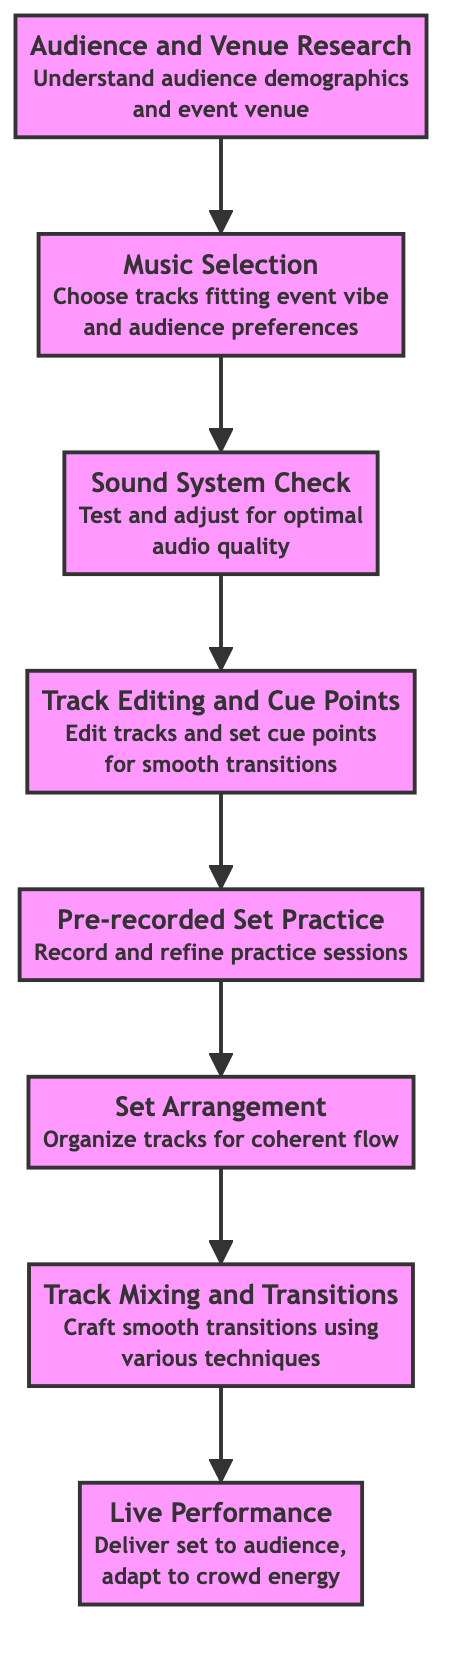What is the first step in planning a DJ set? The diagram indicates that the first step is "Audience and Venue Research," which is at the bottom and leads to music selection.
Answer: Audience and Venue Research How many nodes are in the flowchart? Counting all the elements listed in the diagram, there are eight distinct nodes representing different steps in planning a DJ set.
Answer: Eight Which step directly follows "Music Selection"? According to the diagram, the step that follows "Music Selection" is "Sound System Check." This is determined by the upward flow from node 07 to node 06.
Answer: Sound System Check What is the last step before the live performance? The diagram shows that the step prior to "Live Performance" is "Track Mixing and Transitions," which indicates that the transitions should be polished just before performing live.
Answer: Track Mixing and Transitions Why is "Pre-recorded Set Practice" important? The diagram implies the importance of "Pre-recorded Set Practice" as it allows the DJ to refine transitions and overall set flow, indicating it serves as a critical revision step before the live performance.
Answer: Refine transitions How does "Set Arrangement" relate to "Music Selection"? "Set Arrangement" follows "Music Selection" in the flowchart, indicating that after selecting music, the next logical step is to organize it into a coherent set, showcasing a dependency in the sequence of actions.
Answer: It follows What is the purpose of the "Sound System Check"? The diagram specifies the purpose as to "Test and adjust for optimal audio quality," highlighting its role in ensuring the performance's sound quality before the live event.
Answer: Optimal audio quality In what order do the steps flow from "Track Editing and Cue Points" to "Live Performance"? The steps flow as follows: "Track Editing and Cue Points" goes to "Pre-recorded Set Practice," then to "Set Arrangement," followed by "Track Mixing and Transitions," and finally to "Live Performance," indicating a stepwise progression.
Answer: Five steps 